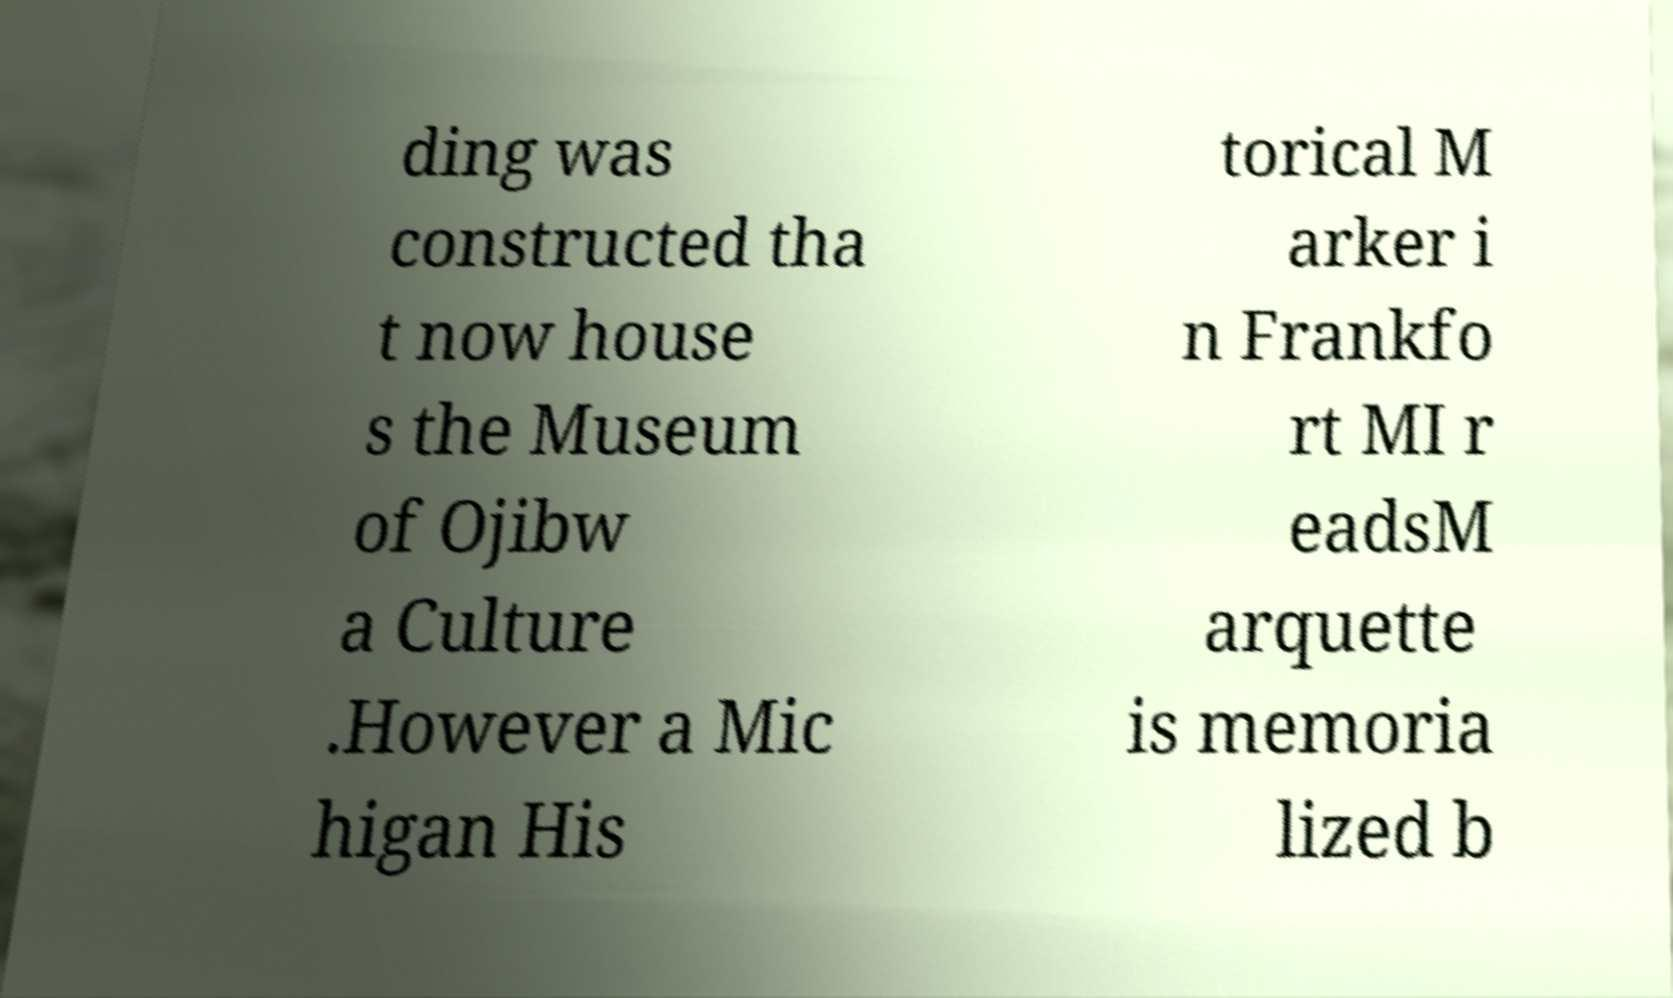There's text embedded in this image that I need extracted. Can you transcribe it verbatim? ding was constructed tha t now house s the Museum of Ojibw a Culture .However a Mic higan His torical M arker i n Frankfo rt MI r eadsM arquette is memoria lized b 